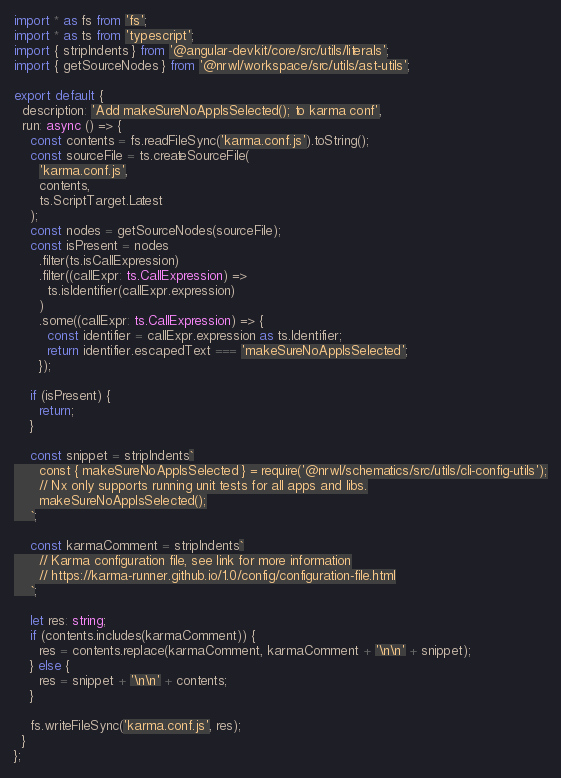<code> <loc_0><loc_0><loc_500><loc_500><_TypeScript_>import * as fs from 'fs';
import * as ts from 'typescript';
import { stripIndents } from '@angular-devkit/core/src/utils/literals';
import { getSourceNodes } from '@nrwl/workspace/src/utils/ast-utils';

export default {
  description: 'Add makeSureNoAppIsSelected(); to karma conf',
  run: async () => {
    const contents = fs.readFileSync('karma.conf.js').toString();
    const sourceFile = ts.createSourceFile(
      'karma.conf.js',
      contents,
      ts.ScriptTarget.Latest
    );
    const nodes = getSourceNodes(sourceFile);
    const isPresent = nodes
      .filter(ts.isCallExpression)
      .filter((callExpr: ts.CallExpression) =>
        ts.isIdentifier(callExpr.expression)
      )
      .some((callExpr: ts.CallExpression) => {
        const identifier = callExpr.expression as ts.Identifier;
        return identifier.escapedText === 'makeSureNoAppIsSelected';
      });

    if (isPresent) {
      return;
    }

    const snippet = stripIndents`
      const { makeSureNoAppIsSelected } = require('@nrwl/schematics/src/utils/cli-config-utils');
      // Nx only supports running unit tests for all apps and libs.
      makeSureNoAppIsSelected();
    `;

    const karmaComment = stripIndents`
      // Karma configuration file, see link for more information
      // https://karma-runner.github.io/1.0/config/configuration-file.html
    `;

    let res: string;
    if (contents.includes(karmaComment)) {
      res = contents.replace(karmaComment, karmaComment + '\n\n' + snippet);
    } else {
      res = snippet + '\n\n' + contents;
    }

    fs.writeFileSync('karma.conf.js', res);
  }
};
</code> 